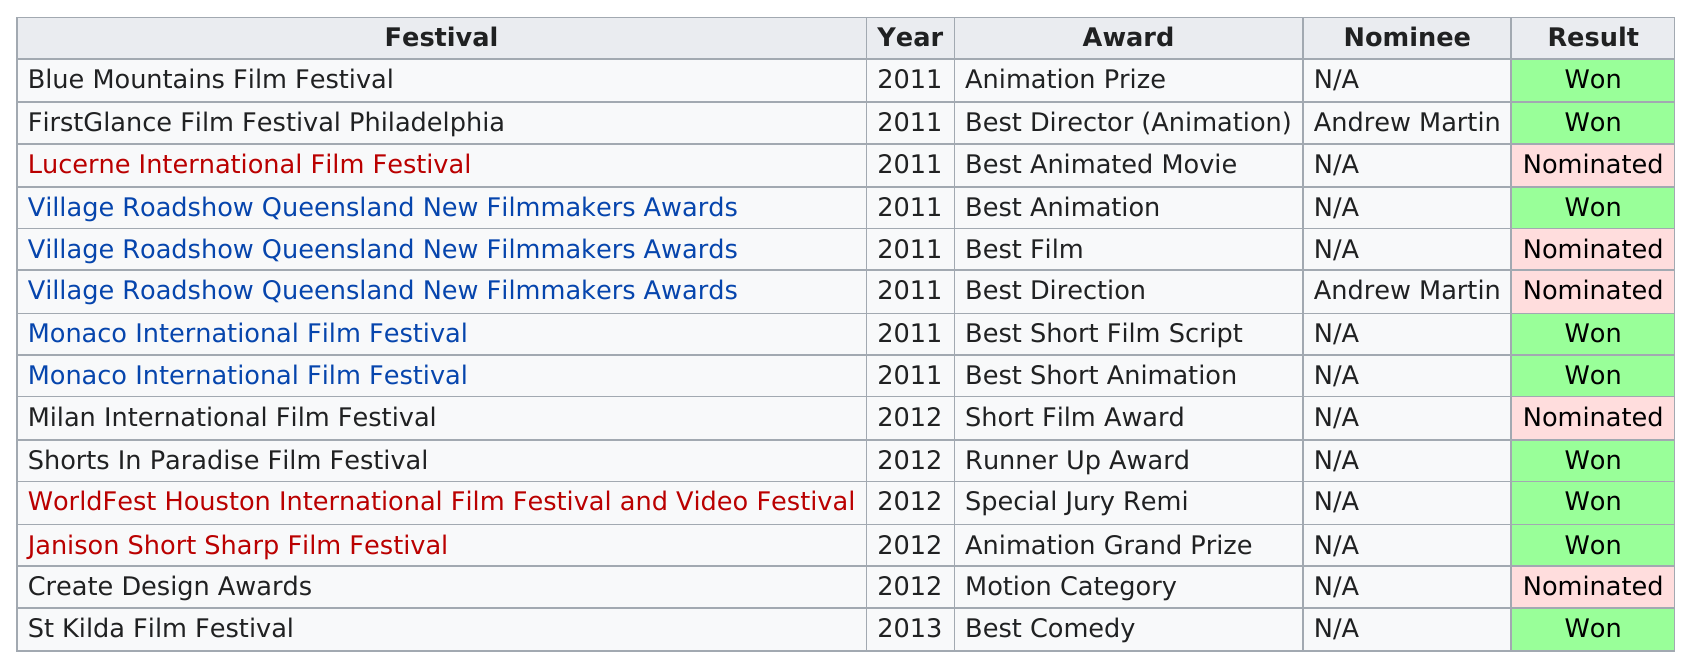Identify some key points in this picture. There were 4 more winners than nominees. The Monaco International Film Festival has won the most awards of any festival. Village Roadshow Queensland New Filmmakers Awards has won a total of 1 time. After 2012, a total of 1 festival was held. The St Kilda Film Festival was the only festival held in 2013. 